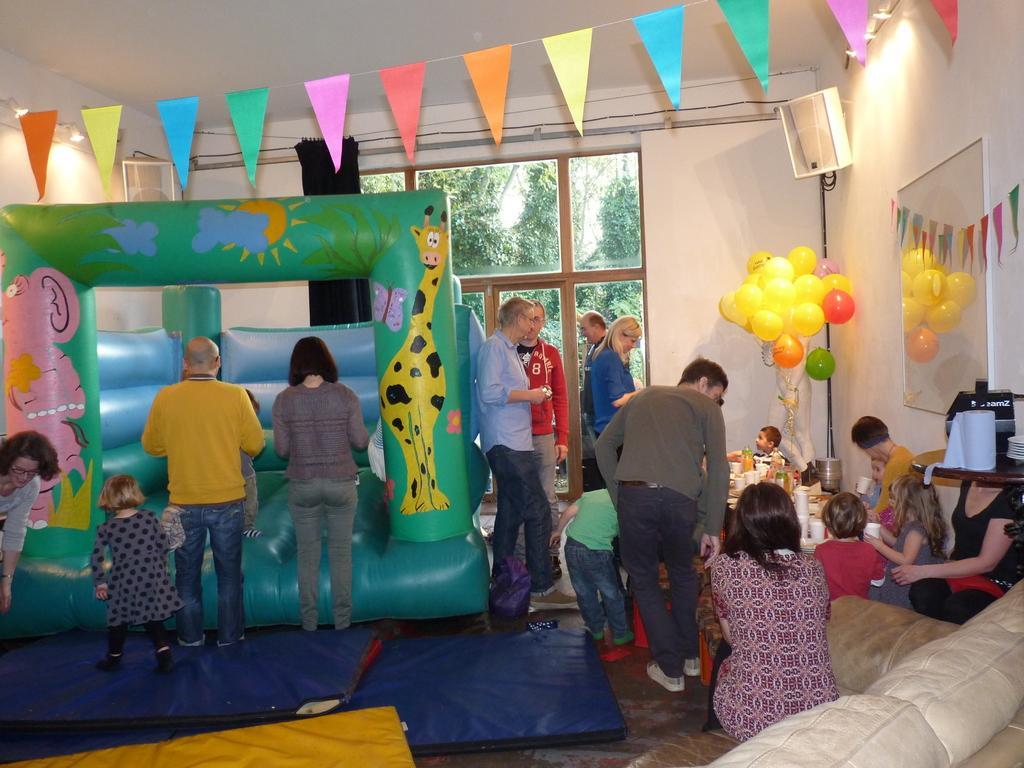How would you summarize this image in a sentence or two? In this picture we can see an inflatable object, group of people, balloons, decorative flags, board on the wall, speakers, tissue paper roll, sofa with a person sitting on it and some objects and in the background we can see trees. 